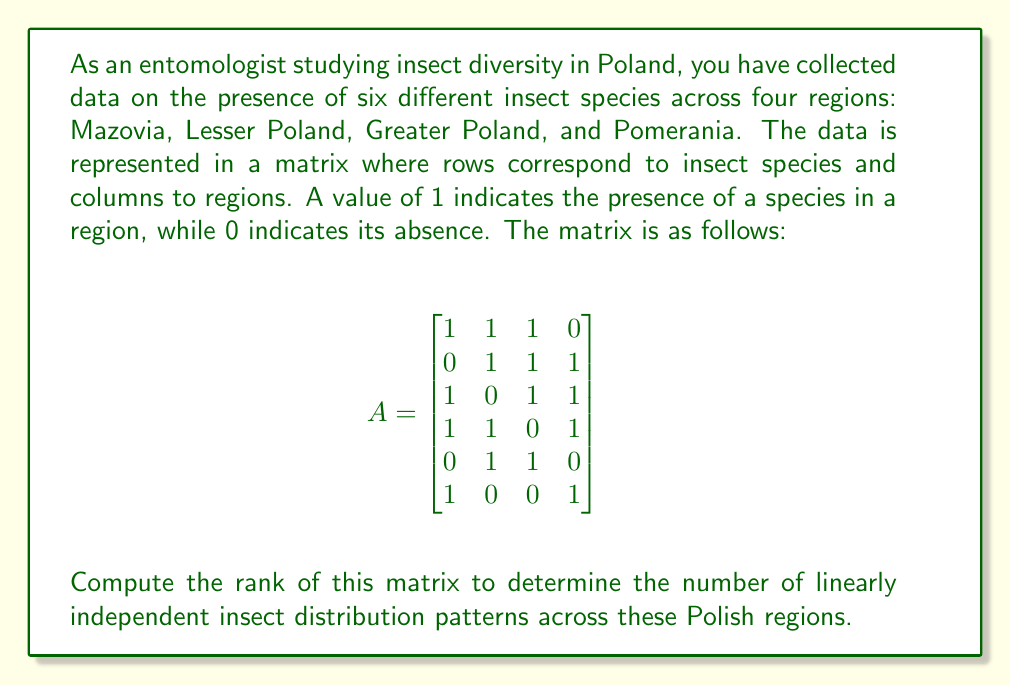Provide a solution to this math problem. To find the rank of the matrix, we need to determine the number of linearly independent rows or columns. We can do this by transforming the matrix into row echelon form using Gaussian elimination.

Step 1: The first row is already in the correct form, so we keep it as is.

Step 2: Use the first row to eliminate the 1 in the third and fourth rows of the first column:

$$
\begin{bmatrix}
1 & 1 & 1 & 0 \\
0 & 1 & 1 & 1 \\
0 & -1 & 0 & 1 \\
0 & 0 & -1 & 1 \\
0 & 1 & 1 & 0 \\
0 & -1 & -1 & 1
\end{bmatrix}
$$

Step 3: Use the second row to eliminate the 1 in the fifth row of the second column:

$$
\begin{bmatrix}
1 & 1 & 1 & 0 \\
0 & 1 & 1 & 1 \\
0 & -1 & 0 & 1 \\
0 & 0 & -1 & 1 \\
0 & 0 & 0 & -1 \\
0 & -1 & -1 & 1
\end{bmatrix}
$$

Step 4: Use the third row to eliminate the -1 in the sixth row of the second column:

$$
\begin{bmatrix}
1 & 1 & 1 & 0 \\
0 & 1 & 1 & 1 \\
0 & -1 & 0 & 1 \\
0 & 0 & -1 & 1 \\
0 & 0 & 0 & -1 \\
0 & 0 & -1 & 2
\end{bmatrix}
$$

Step 5: Use the fourth row to eliminate the -1 in the sixth row of the third column:

$$
\begin{bmatrix}
1 & 1 & 1 & 0 \\
0 & 1 & 1 & 1 \\
0 & -1 & 0 & 1 \\
0 & 0 & -1 & 1 \\
0 & 0 & 0 & -1 \\
0 & 0 & 0 & 3
\end{bmatrix}
$$

Now the matrix is in row echelon form. The rank of the matrix is equal to the number of non-zero rows in this form, which is 4.

This means there are 4 linearly independent insect distribution patterns across the Polish regions studied.
Answer: The rank of the matrix is 4. 